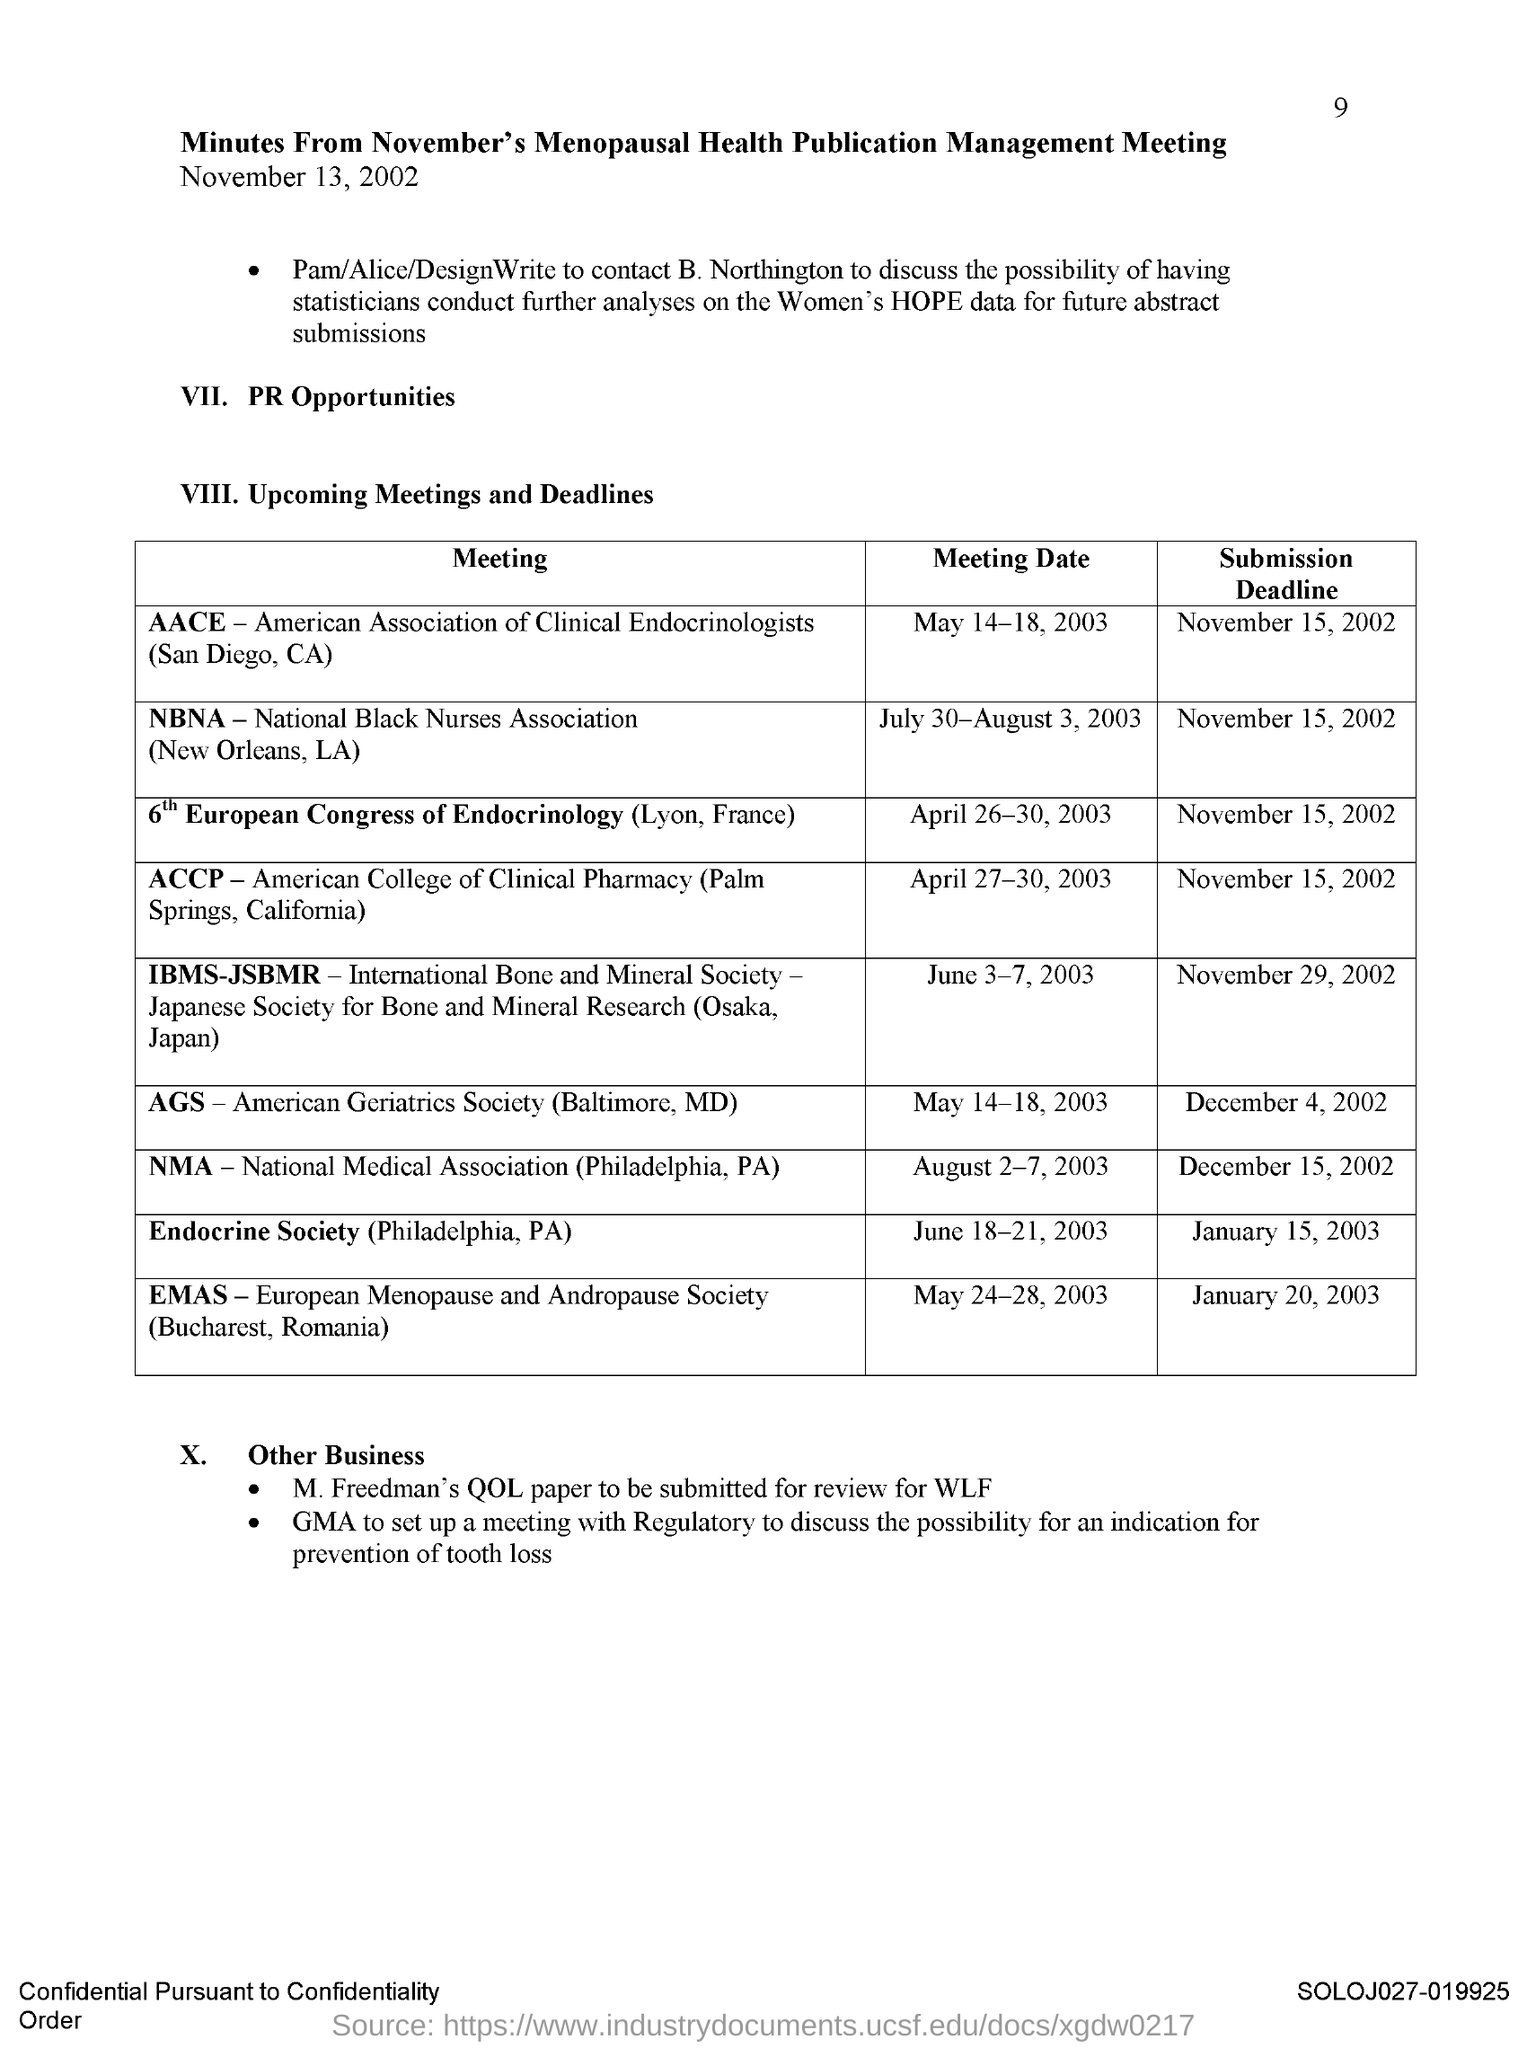List a handful of essential elements in this visual. The submission deadline for the NBNA meeting is November 15, 2002. The submission deadline for the EMAS meeting is January 20, 2003. The submission deadline for the AGS meeting is December 4, 2002. The submission deadline for the AACE Meeting is November 15, 2002. The submission deadline for the ACCP meeting is November 15, 2002. 